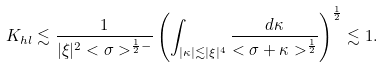Convert formula to latex. <formula><loc_0><loc_0><loc_500><loc_500>K _ { h l } \lesssim \frac { 1 } { | \xi | ^ { 2 } < \sigma > ^ { \frac { 1 } { 2 } - } } \left ( \int _ { | \kappa | \lesssim | \xi | ^ { 4 } } \frac { d \kappa } { < \sigma + \kappa > ^ { \frac { 1 } { 2 } } } \right ) ^ { \frac { 1 } { 2 } } \lesssim 1 .</formula> 